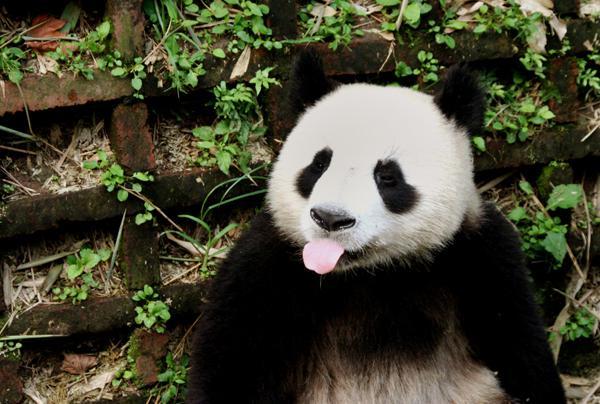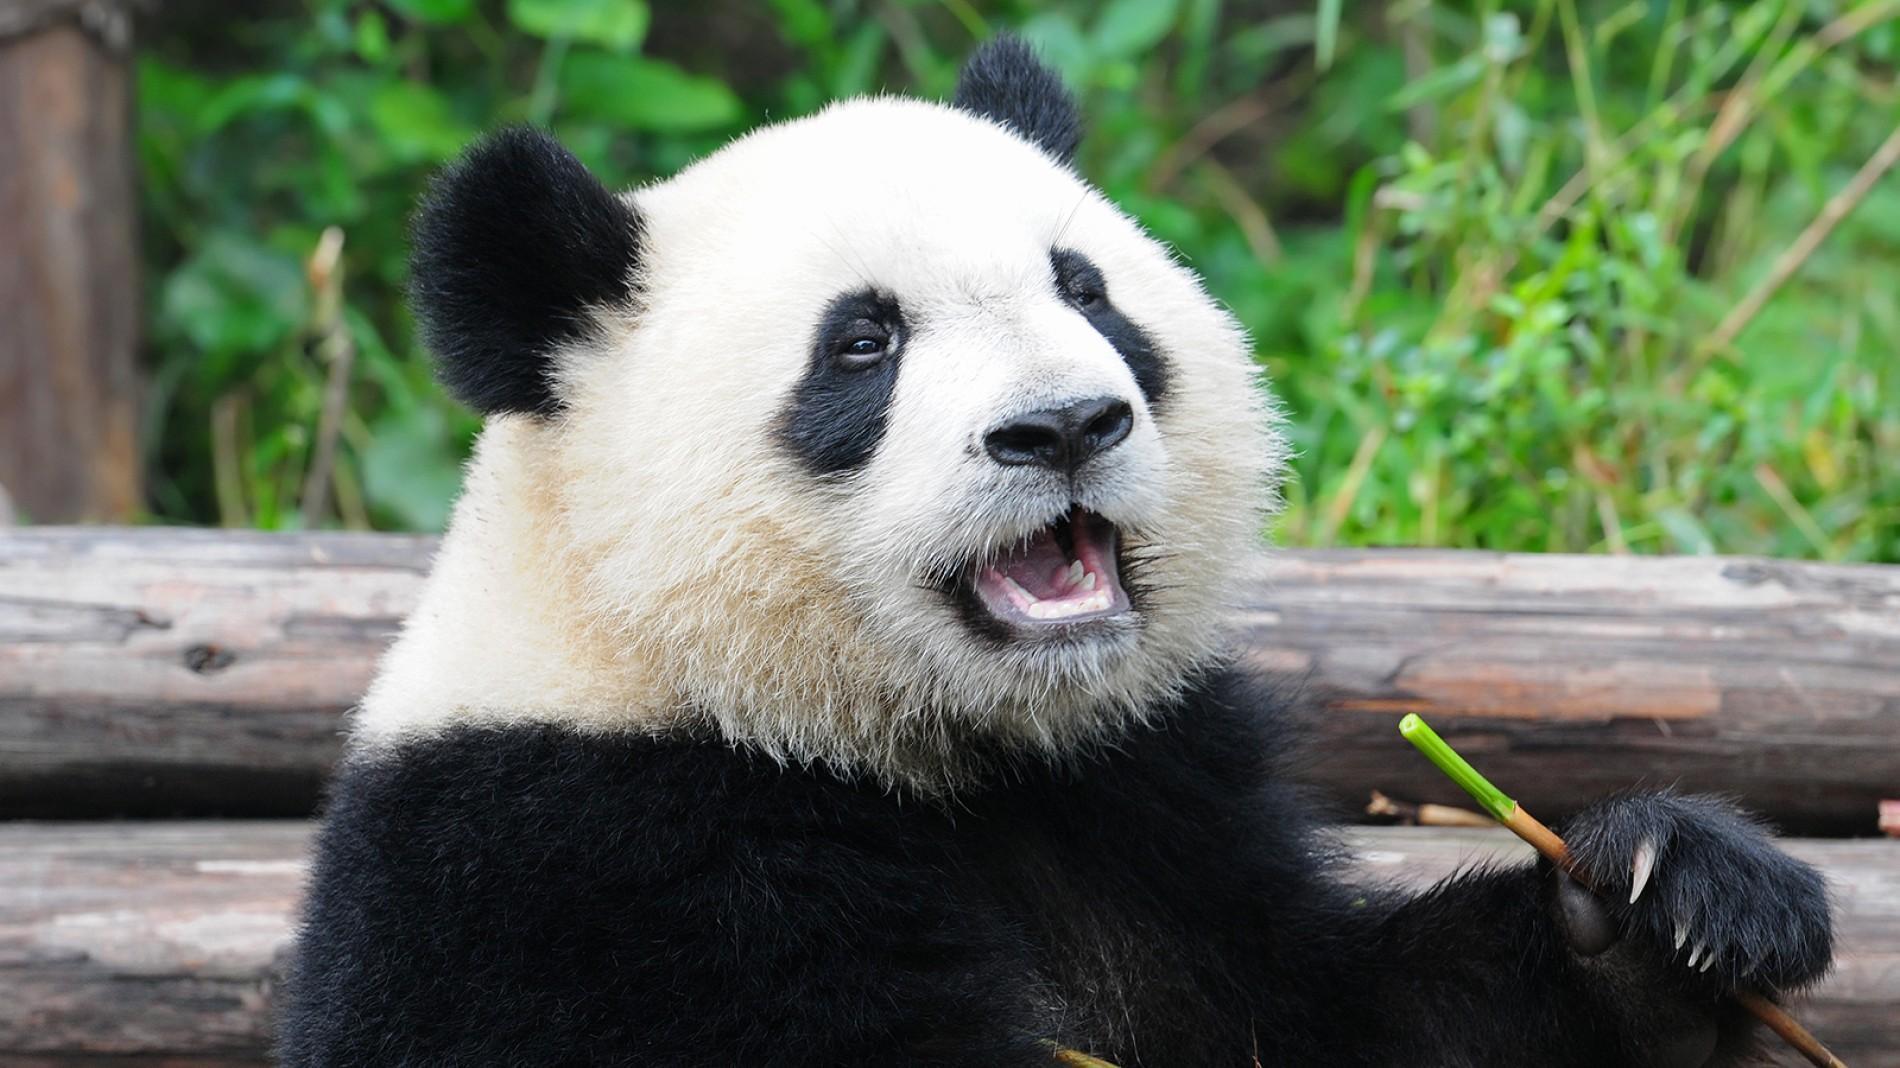The first image is the image on the left, the second image is the image on the right. Given the left and right images, does the statement "There are at most two panda bears." hold true? Answer yes or no. Yes. The first image is the image on the left, the second image is the image on the right. Considering the images on both sides, is "One image contains twice as many pandas as the other image and features two pandas facing generally toward each other." valid? Answer yes or no. No. 